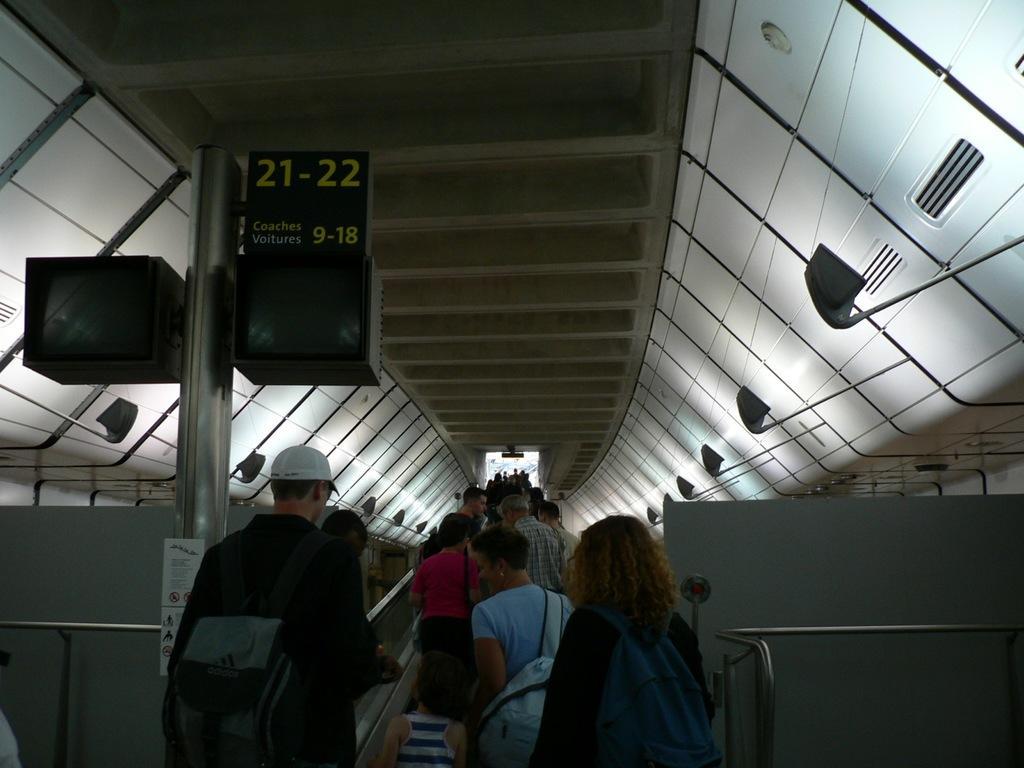Describe this image in one or two sentences. In this image I can see a group of people are moving through an escalator. On the left side there is a board. 